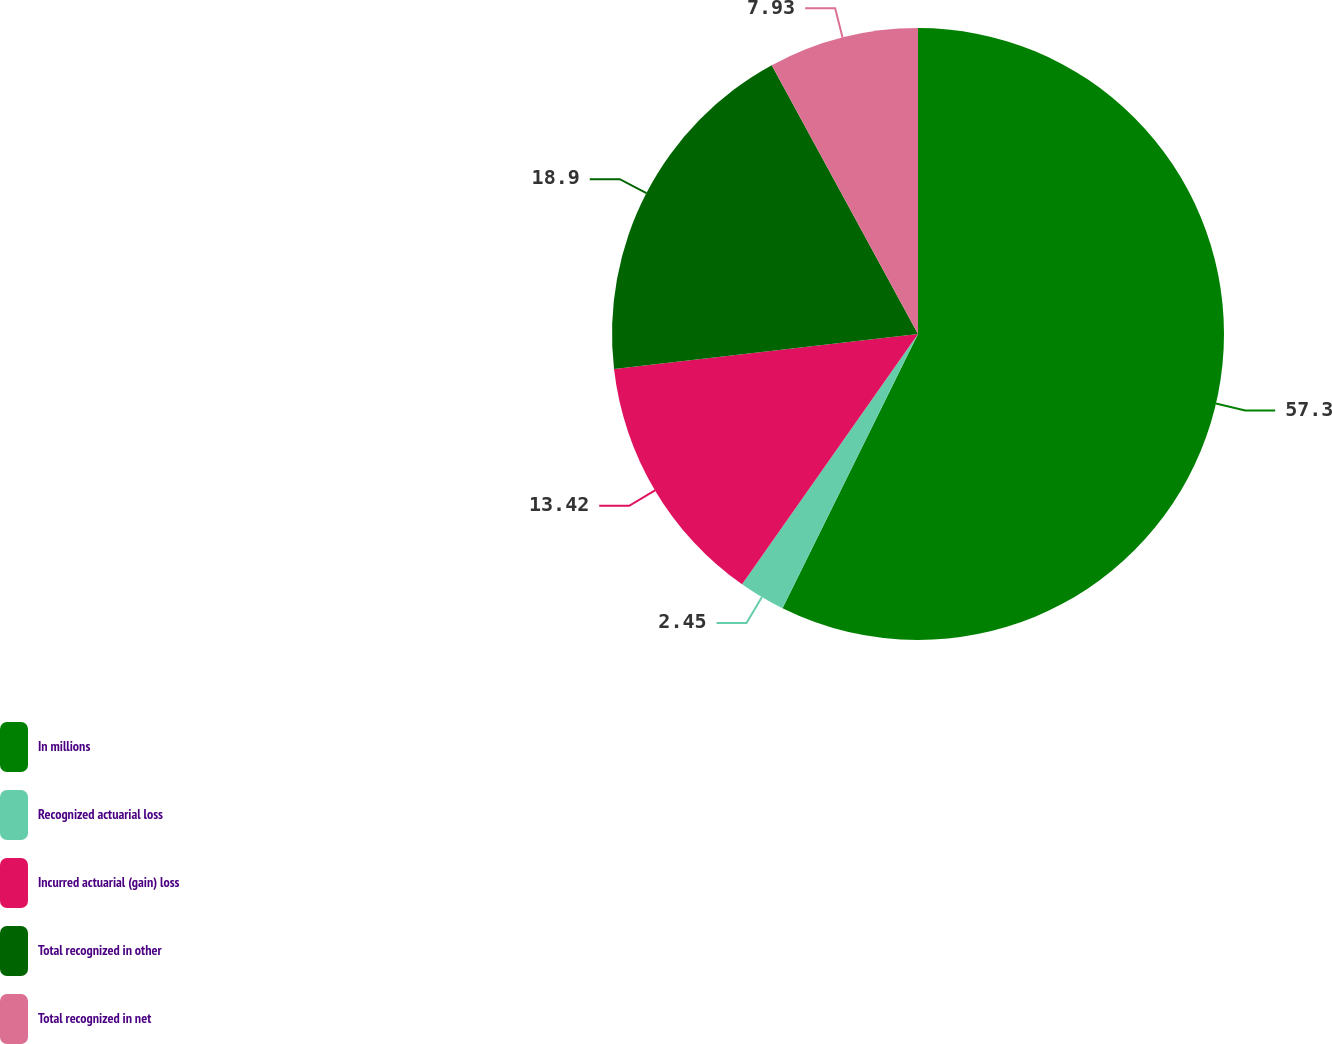Convert chart. <chart><loc_0><loc_0><loc_500><loc_500><pie_chart><fcel>In millions<fcel>Recognized actuarial loss<fcel>Incurred actuarial (gain) loss<fcel>Total recognized in other<fcel>Total recognized in net<nl><fcel>57.3%<fcel>2.45%<fcel>13.42%<fcel>18.9%<fcel>7.93%<nl></chart> 